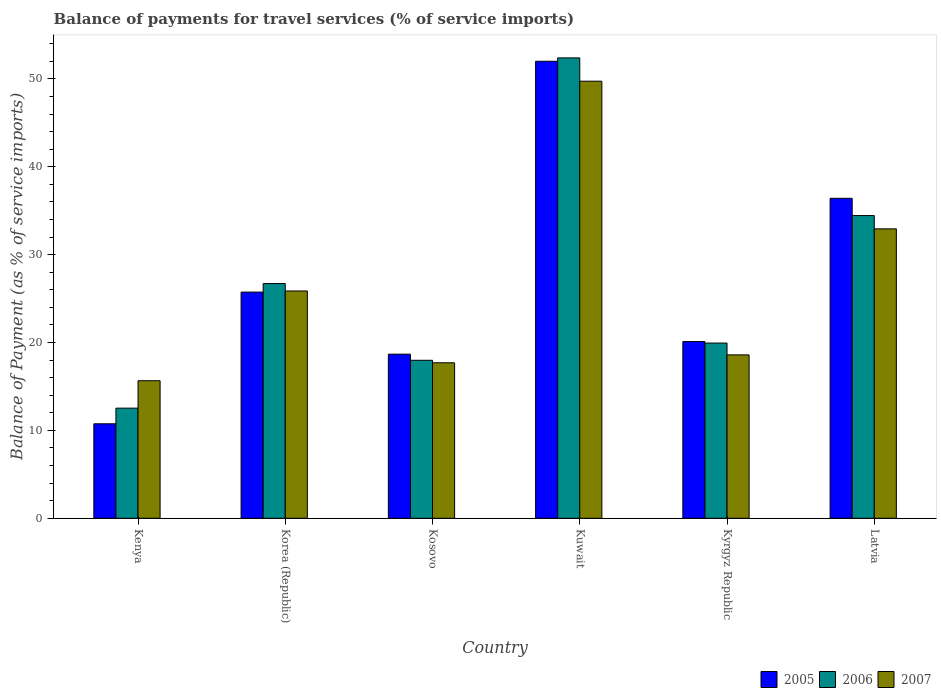How many different coloured bars are there?
Provide a short and direct response. 3. Are the number of bars per tick equal to the number of legend labels?
Keep it short and to the point. Yes. Are the number of bars on each tick of the X-axis equal?
Keep it short and to the point. Yes. What is the label of the 5th group of bars from the left?
Provide a succinct answer. Kyrgyz Republic. What is the balance of payments for travel services in 2007 in Latvia?
Offer a terse response. 32.93. Across all countries, what is the maximum balance of payments for travel services in 2007?
Your answer should be very brief. 49.73. Across all countries, what is the minimum balance of payments for travel services in 2006?
Keep it short and to the point. 12.53. In which country was the balance of payments for travel services in 2005 maximum?
Ensure brevity in your answer.  Kuwait. In which country was the balance of payments for travel services in 2005 minimum?
Your answer should be very brief. Kenya. What is the total balance of payments for travel services in 2007 in the graph?
Give a very brief answer. 160.46. What is the difference between the balance of payments for travel services in 2005 in Kenya and that in Kosovo?
Keep it short and to the point. -7.92. What is the difference between the balance of payments for travel services in 2007 in Korea (Republic) and the balance of payments for travel services in 2005 in Kuwait?
Your answer should be very brief. -26.14. What is the average balance of payments for travel services in 2006 per country?
Keep it short and to the point. 27.33. What is the difference between the balance of payments for travel services of/in 2007 and balance of payments for travel services of/in 2005 in Latvia?
Provide a short and direct response. -3.47. In how many countries, is the balance of payments for travel services in 2006 greater than 32 %?
Make the answer very short. 2. What is the ratio of the balance of payments for travel services in 2005 in Korea (Republic) to that in Kosovo?
Keep it short and to the point. 1.38. Is the balance of payments for travel services in 2006 in Kyrgyz Republic less than that in Latvia?
Your answer should be compact. Yes. Is the difference between the balance of payments for travel services in 2007 in Kosovo and Kuwait greater than the difference between the balance of payments for travel services in 2005 in Kosovo and Kuwait?
Provide a succinct answer. Yes. What is the difference between the highest and the second highest balance of payments for travel services in 2007?
Keep it short and to the point. -16.8. What is the difference between the highest and the lowest balance of payments for travel services in 2007?
Provide a short and direct response. 34.08. Is the sum of the balance of payments for travel services in 2006 in Kosovo and Latvia greater than the maximum balance of payments for travel services in 2007 across all countries?
Make the answer very short. Yes. What does the 2nd bar from the left in Kenya represents?
Offer a terse response. 2006. What does the 1st bar from the right in Kenya represents?
Offer a terse response. 2007. Is it the case that in every country, the sum of the balance of payments for travel services in 2006 and balance of payments for travel services in 2005 is greater than the balance of payments for travel services in 2007?
Ensure brevity in your answer.  Yes. How many bars are there?
Your response must be concise. 18. Are all the bars in the graph horizontal?
Offer a terse response. No. Does the graph contain any zero values?
Your answer should be very brief. No. Does the graph contain grids?
Offer a terse response. No. Where does the legend appear in the graph?
Your answer should be compact. Bottom right. What is the title of the graph?
Keep it short and to the point. Balance of payments for travel services (% of service imports). What is the label or title of the X-axis?
Your answer should be very brief. Country. What is the label or title of the Y-axis?
Make the answer very short. Balance of Payment (as % of service imports). What is the Balance of Payment (as % of service imports) of 2005 in Kenya?
Keep it short and to the point. 10.75. What is the Balance of Payment (as % of service imports) in 2006 in Kenya?
Provide a succinct answer. 12.53. What is the Balance of Payment (as % of service imports) of 2007 in Kenya?
Make the answer very short. 15.65. What is the Balance of Payment (as % of service imports) in 2005 in Korea (Republic)?
Make the answer very short. 25.74. What is the Balance of Payment (as % of service imports) in 2006 in Korea (Republic)?
Give a very brief answer. 26.71. What is the Balance of Payment (as % of service imports) of 2007 in Korea (Republic)?
Ensure brevity in your answer.  25.86. What is the Balance of Payment (as % of service imports) in 2005 in Kosovo?
Your answer should be compact. 18.67. What is the Balance of Payment (as % of service imports) of 2006 in Kosovo?
Provide a short and direct response. 17.98. What is the Balance of Payment (as % of service imports) in 2007 in Kosovo?
Your answer should be compact. 17.69. What is the Balance of Payment (as % of service imports) of 2005 in Kuwait?
Your answer should be very brief. 52. What is the Balance of Payment (as % of service imports) of 2006 in Kuwait?
Give a very brief answer. 52.38. What is the Balance of Payment (as % of service imports) of 2007 in Kuwait?
Offer a terse response. 49.73. What is the Balance of Payment (as % of service imports) of 2005 in Kyrgyz Republic?
Provide a short and direct response. 20.11. What is the Balance of Payment (as % of service imports) in 2006 in Kyrgyz Republic?
Keep it short and to the point. 19.94. What is the Balance of Payment (as % of service imports) in 2007 in Kyrgyz Republic?
Give a very brief answer. 18.59. What is the Balance of Payment (as % of service imports) of 2005 in Latvia?
Your answer should be very brief. 36.41. What is the Balance of Payment (as % of service imports) in 2006 in Latvia?
Your answer should be very brief. 34.44. What is the Balance of Payment (as % of service imports) of 2007 in Latvia?
Offer a terse response. 32.93. Across all countries, what is the maximum Balance of Payment (as % of service imports) in 2005?
Make the answer very short. 52. Across all countries, what is the maximum Balance of Payment (as % of service imports) of 2006?
Your response must be concise. 52.38. Across all countries, what is the maximum Balance of Payment (as % of service imports) of 2007?
Provide a succinct answer. 49.73. Across all countries, what is the minimum Balance of Payment (as % of service imports) of 2005?
Keep it short and to the point. 10.75. Across all countries, what is the minimum Balance of Payment (as % of service imports) in 2006?
Keep it short and to the point. 12.53. Across all countries, what is the minimum Balance of Payment (as % of service imports) of 2007?
Keep it short and to the point. 15.65. What is the total Balance of Payment (as % of service imports) of 2005 in the graph?
Your answer should be compact. 163.68. What is the total Balance of Payment (as % of service imports) in 2006 in the graph?
Keep it short and to the point. 163.98. What is the total Balance of Payment (as % of service imports) of 2007 in the graph?
Keep it short and to the point. 160.46. What is the difference between the Balance of Payment (as % of service imports) of 2005 in Kenya and that in Korea (Republic)?
Make the answer very short. -14.99. What is the difference between the Balance of Payment (as % of service imports) in 2006 in Kenya and that in Korea (Republic)?
Offer a very short reply. -14.18. What is the difference between the Balance of Payment (as % of service imports) in 2007 in Kenya and that in Korea (Republic)?
Make the answer very short. -10.21. What is the difference between the Balance of Payment (as % of service imports) in 2005 in Kenya and that in Kosovo?
Your response must be concise. -7.92. What is the difference between the Balance of Payment (as % of service imports) in 2006 in Kenya and that in Kosovo?
Make the answer very short. -5.44. What is the difference between the Balance of Payment (as % of service imports) of 2007 in Kenya and that in Kosovo?
Offer a terse response. -2.04. What is the difference between the Balance of Payment (as % of service imports) in 2005 in Kenya and that in Kuwait?
Provide a succinct answer. -41.25. What is the difference between the Balance of Payment (as % of service imports) in 2006 in Kenya and that in Kuwait?
Your answer should be very brief. -39.85. What is the difference between the Balance of Payment (as % of service imports) in 2007 in Kenya and that in Kuwait?
Provide a succinct answer. -34.08. What is the difference between the Balance of Payment (as % of service imports) in 2005 in Kenya and that in Kyrgyz Republic?
Make the answer very short. -9.36. What is the difference between the Balance of Payment (as % of service imports) in 2006 in Kenya and that in Kyrgyz Republic?
Offer a terse response. -7.41. What is the difference between the Balance of Payment (as % of service imports) of 2007 in Kenya and that in Kyrgyz Republic?
Offer a very short reply. -2.94. What is the difference between the Balance of Payment (as % of service imports) of 2005 in Kenya and that in Latvia?
Keep it short and to the point. -25.66. What is the difference between the Balance of Payment (as % of service imports) of 2006 in Kenya and that in Latvia?
Your response must be concise. -21.91. What is the difference between the Balance of Payment (as % of service imports) of 2007 in Kenya and that in Latvia?
Make the answer very short. -17.28. What is the difference between the Balance of Payment (as % of service imports) in 2005 in Korea (Republic) and that in Kosovo?
Offer a terse response. 7.06. What is the difference between the Balance of Payment (as % of service imports) in 2006 in Korea (Republic) and that in Kosovo?
Offer a very short reply. 8.73. What is the difference between the Balance of Payment (as % of service imports) in 2007 in Korea (Republic) and that in Kosovo?
Give a very brief answer. 8.17. What is the difference between the Balance of Payment (as % of service imports) of 2005 in Korea (Republic) and that in Kuwait?
Keep it short and to the point. -26.27. What is the difference between the Balance of Payment (as % of service imports) in 2006 in Korea (Republic) and that in Kuwait?
Provide a succinct answer. -25.68. What is the difference between the Balance of Payment (as % of service imports) of 2007 in Korea (Republic) and that in Kuwait?
Ensure brevity in your answer.  -23.87. What is the difference between the Balance of Payment (as % of service imports) in 2005 in Korea (Republic) and that in Kyrgyz Republic?
Provide a succinct answer. 5.63. What is the difference between the Balance of Payment (as % of service imports) of 2006 in Korea (Republic) and that in Kyrgyz Republic?
Provide a short and direct response. 6.77. What is the difference between the Balance of Payment (as % of service imports) of 2007 in Korea (Republic) and that in Kyrgyz Republic?
Offer a very short reply. 7.27. What is the difference between the Balance of Payment (as % of service imports) of 2005 in Korea (Republic) and that in Latvia?
Provide a succinct answer. -10.67. What is the difference between the Balance of Payment (as % of service imports) of 2006 in Korea (Republic) and that in Latvia?
Your answer should be compact. -7.74. What is the difference between the Balance of Payment (as % of service imports) of 2007 in Korea (Republic) and that in Latvia?
Ensure brevity in your answer.  -7.07. What is the difference between the Balance of Payment (as % of service imports) in 2005 in Kosovo and that in Kuwait?
Your answer should be very brief. -33.33. What is the difference between the Balance of Payment (as % of service imports) of 2006 in Kosovo and that in Kuwait?
Offer a terse response. -34.41. What is the difference between the Balance of Payment (as % of service imports) of 2007 in Kosovo and that in Kuwait?
Your answer should be very brief. -32.04. What is the difference between the Balance of Payment (as % of service imports) of 2005 in Kosovo and that in Kyrgyz Republic?
Keep it short and to the point. -1.44. What is the difference between the Balance of Payment (as % of service imports) in 2006 in Kosovo and that in Kyrgyz Republic?
Make the answer very short. -1.96. What is the difference between the Balance of Payment (as % of service imports) of 2007 in Kosovo and that in Kyrgyz Republic?
Give a very brief answer. -0.9. What is the difference between the Balance of Payment (as % of service imports) in 2005 in Kosovo and that in Latvia?
Provide a short and direct response. -17.73. What is the difference between the Balance of Payment (as % of service imports) in 2006 in Kosovo and that in Latvia?
Keep it short and to the point. -16.47. What is the difference between the Balance of Payment (as % of service imports) in 2007 in Kosovo and that in Latvia?
Keep it short and to the point. -15.24. What is the difference between the Balance of Payment (as % of service imports) in 2005 in Kuwait and that in Kyrgyz Republic?
Give a very brief answer. 31.89. What is the difference between the Balance of Payment (as % of service imports) of 2006 in Kuwait and that in Kyrgyz Republic?
Offer a terse response. 32.45. What is the difference between the Balance of Payment (as % of service imports) in 2007 in Kuwait and that in Kyrgyz Republic?
Offer a very short reply. 31.14. What is the difference between the Balance of Payment (as % of service imports) in 2005 in Kuwait and that in Latvia?
Offer a very short reply. 15.6. What is the difference between the Balance of Payment (as % of service imports) of 2006 in Kuwait and that in Latvia?
Make the answer very short. 17.94. What is the difference between the Balance of Payment (as % of service imports) in 2007 in Kuwait and that in Latvia?
Give a very brief answer. 16.8. What is the difference between the Balance of Payment (as % of service imports) in 2005 in Kyrgyz Republic and that in Latvia?
Provide a short and direct response. -16.3. What is the difference between the Balance of Payment (as % of service imports) of 2006 in Kyrgyz Republic and that in Latvia?
Offer a terse response. -14.51. What is the difference between the Balance of Payment (as % of service imports) in 2007 in Kyrgyz Republic and that in Latvia?
Ensure brevity in your answer.  -14.34. What is the difference between the Balance of Payment (as % of service imports) of 2005 in Kenya and the Balance of Payment (as % of service imports) of 2006 in Korea (Republic)?
Offer a terse response. -15.96. What is the difference between the Balance of Payment (as % of service imports) in 2005 in Kenya and the Balance of Payment (as % of service imports) in 2007 in Korea (Republic)?
Keep it short and to the point. -15.11. What is the difference between the Balance of Payment (as % of service imports) of 2006 in Kenya and the Balance of Payment (as % of service imports) of 2007 in Korea (Republic)?
Keep it short and to the point. -13.33. What is the difference between the Balance of Payment (as % of service imports) of 2005 in Kenya and the Balance of Payment (as % of service imports) of 2006 in Kosovo?
Provide a succinct answer. -7.23. What is the difference between the Balance of Payment (as % of service imports) in 2005 in Kenya and the Balance of Payment (as % of service imports) in 2007 in Kosovo?
Your response must be concise. -6.94. What is the difference between the Balance of Payment (as % of service imports) of 2006 in Kenya and the Balance of Payment (as % of service imports) of 2007 in Kosovo?
Offer a terse response. -5.16. What is the difference between the Balance of Payment (as % of service imports) of 2005 in Kenya and the Balance of Payment (as % of service imports) of 2006 in Kuwait?
Your response must be concise. -41.63. What is the difference between the Balance of Payment (as % of service imports) in 2005 in Kenya and the Balance of Payment (as % of service imports) in 2007 in Kuwait?
Your response must be concise. -38.98. What is the difference between the Balance of Payment (as % of service imports) in 2006 in Kenya and the Balance of Payment (as % of service imports) in 2007 in Kuwait?
Provide a short and direct response. -37.2. What is the difference between the Balance of Payment (as % of service imports) of 2005 in Kenya and the Balance of Payment (as % of service imports) of 2006 in Kyrgyz Republic?
Keep it short and to the point. -9.19. What is the difference between the Balance of Payment (as % of service imports) of 2005 in Kenya and the Balance of Payment (as % of service imports) of 2007 in Kyrgyz Republic?
Provide a succinct answer. -7.84. What is the difference between the Balance of Payment (as % of service imports) in 2006 in Kenya and the Balance of Payment (as % of service imports) in 2007 in Kyrgyz Republic?
Give a very brief answer. -6.06. What is the difference between the Balance of Payment (as % of service imports) of 2005 in Kenya and the Balance of Payment (as % of service imports) of 2006 in Latvia?
Keep it short and to the point. -23.69. What is the difference between the Balance of Payment (as % of service imports) in 2005 in Kenya and the Balance of Payment (as % of service imports) in 2007 in Latvia?
Make the answer very short. -22.18. What is the difference between the Balance of Payment (as % of service imports) of 2006 in Kenya and the Balance of Payment (as % of service imports) of 2007 in Latvia?
Provide a short and direct response. -20.4. What is the difference between the Balance of Payment (as % of service imports) in 2005 in Korea (Republic) and the Balance of Payment (as % of service imports) in 2006 in Kosovo?
Ensure brevity in your answer.  7.76. What is the difference between the Balance of Payment (as % of service imports) of 2005 in Korea (Republic) and the Balance of Payment (as % of service imports) of 2007 in Kosovo?
Ensure brevity in your answer.  8.04. What is the difference between the Balance of Payment (as % of service imports) of 2006 in Korea (Republic) and the Balance of Payment (as % of service imports) of 2007 in Kosovo?
Your response must be concise. 9.02. What is the difference between the Balance of Payment (as % of service imports) of 2005 in Korea (Republic) and the Balance of Payment (as % of service imports) of 2006 in Kuwait?
Your answer should be compact. -26.65. What is the difference between the Balance of Payment (as % of service imports) in 2005 in Korea (Republic) and the Balance of Payment (as % of service imports) in 2007 in Kuwait?
Your answer should be very brief. -24. What is the difference between the Balance of Payment (as % of service imports) of 2006 in Korea (Republic) and the Balance of Payment (as % of service imports) of 2007 in Kuwait?
Offer a very short reply. -23.02. What is the difference between the Balance of Payment (as % of service imports) of 2005 in Korea (Republic) and the Balance of Payment (as % of service imports) of 2006 in Kyrgyz Republic?
Provide a short and direct response. 5.8. What is the difference between the Balance of Payment (as % of service imports) of 2005 in Korea (Republic) and the Balance of Payment (as % of service imports) of 2007 in Kyrgyz Republic?
Your answer should be very brief. 7.15. What is the difference between the Balance of Payment (as % of service imports) in 2006 in Korea (Republic) and the Balance of Payment (as % of service imports) in 2007 in Kyrgyz Republic?
Offer a terse response. 8.12. What is the difference between the Balance of Payment (as % of service imports) in 2005 in Korea (Republic) and the Balance of Payment (as % of service imports) in 2006 in Latvia?
Your response must be concise. -8.71. What is the difference between the Balance of Payment (as % of service imports) of 2005 in Korea (Republic) and the Balance of Payment (as % of service imports) of 2007 in Latvia?
Your answer should be compact. -7.2. What is the difference between the Balance of Payment (as % of service imports) in 2006 in Korea (Republic) and the Balance of Payment (as % of service imports) in 2007 in Latvia?
Offer a very short reply. -6.22. What is the difference between the Balance of Payment (as % of service imports) in 2005 in Kosovo and the Balance of Payment (as % of service imports) in 2006 in Kuwait?
Provide a succinct answer. -33.71. What is the difference between the Balance of Payment (as % of service imports) of 2005 in Kosovo and the Balance of Payment (as % of service imports) of 2007 in Kuwait?
Ensure brevity in your answer.  -31.06. What is the difference between the Balance of Payment (as % of service imports) in 2006 in Kosovo and the Balance of Payment (as % of service imports) in 2007 in Kuwait?
Make the answer very short. -31.76. What is the difference between the Balance of Payment (as % of service imports) in 2005 in Kosovo and the Balance of Payment (as % of service imports) in 2006 in Kyrgyz Republic?
Give a very brief answer. -1.26. What is the difference between the Balance of Payment (as % of service imports) in 2005 in Kosovo and the Balance of Payment (as % of service imports) in 2007 in Kyrgyz Republic?
Provide a succinct answer. 0.08. What is the difference between the Balance of Payment (as % of service imports) of 2006 in Kosovo and the Balance of Payment (as % of service imports) of 2007 in Kyrgyz Republic?
Offer a very short reply. -0.62. What is the difference between the Balance of Payment (as % of service imports) of 2005 in Kosovo and the Balance of Payment (as % of service imports) of 2006 in Latvia?
Your answer should be compact. -15.77. What is the difference between the Balance of Payment (as % of service imports) in 2005 in Kosovo and the Balance of Payment (as % of service imports) in 2007 in Latvia?
Keep it short and to the point. -14.26. What is the difference between the Balance of Payment (as % of service imports) of 2006 in Kosovo and the Balance of Payment (as % of service imports) of 2007 in Latvia?
Ensure brevity in your answer.  -14.96. What is the difference between the Balance of Payment (as % of service imports) of 2005 in Kuwait and the Balance of Payment (as % of service imports) of 2006 in Kyrgyz Republic?
Offer a terse response. 32.07. What is the difference between the Balance of Payment (as % of service imports) of 2005 in Kuwait and the Balance of Payment (as % of service imports) of 2007 in Kyrgyz Republic?
Offer a terse response. 33.41. What is the difference between the Balance of Payment (as % of service imports) of 2006 in Kuwait and the Balance of Payment (as % of service imports) of 2007 in Kyrgyz Republic?
Provide a short and direct response. 33.79. What is the difference between the Balance of Payment (as % of service imports) in 2005 in Kuwait and the Balance of Payment (as % of service imports) in 2006 in Latvia?
Your answer should be compact. 17.56. What is the difference between the Balance of Payment (as % of service imports) in 2005 in Kuwait and the Balance of Payment (as % of service imports) in 2007 in Latvia?
Keep it short and to the point. 19.07. What is the difference between the Balance of Payment (as % of service imports) in 2006 in Kuwait and the Balance of Payment (as % of service imports) in 2007 in Latvia?
Offer a very short reply. 19.45. What is the difference between the Balance of Payment (as % of service imports) of 2005 in Kyrgyz Republic and the Balance of Payment (as % of service imports) of 2006 in Latvia?
Your response must be concise. -14.33. What is the difference between the Balance of Payment (as % of service imports) in 2005 in Kyrgyz Republic and the Balance of Payment (as % of service imports) in 2007 in Latvia?
Provide a short and direct response. -12.82. What is the difference between the Balance of Payment (as % of service imports) of 2006 in Kyrgyz Republic and the Balance of Payment (as % of service imports) of 2007 in Latvia?
Offer a very short reply. -12.99. What is the average Balance of Payment (as % of service imports) of 2005 per country?
Ensure brevity in your answer.  27.28. What is the average Balance of Payment (as % of service imports) in 2006 per country?
Your response must be concise. 27.33. What is the average Balance of Payment (as % of service imports) of 2007 per country?
Keep it short and to the point. 26.74. What is the difference between the Balance of Payment (as % of service imports) of 2005 and Balance of Payment (as % of service imports) of 2006 in Kenya?
Provide a succinct answer. -1.78. What is the difference between the Balance of Payment (as % of service imports) of 2005 and Balance of Payment (as % of service imports) of 2007 in Kenya?
Your response must be concise. -4.9. What is the difference between the Balance of Payment (as % of service imports) of 2006 and Balance of Payment (as % of service imports) of 2007 in Kenya?
Your response must be concise. -3.12. What is the difference between the Balance of Payment (as % of service imports) of 2005 and Balance of Payment (as % of service imports) of 2006 in Korea (Republic)?
Your answer should be very brief. -0.97. What is the difference between the Balance of Payment (as % of service imports) in 2005 and Balance of Payment (as % of service imports) in 2007 in Korea (Republic)?
Offer a terse response. -0.13. What is the difference between the Balance of Payment (as % of service imports) in 2006 and Balance of Payment (as % of service imports) in 2007 in Korea (Republic)?
Your answer should be very brief. 0.84. What is the difference between the Balance of Payment (as % of service imports) of 2005 and Balance of Payment (as % of service imports) of 2006 in Kosovo?
Your answer should be compact. 0.7. What is the difference between the Balance of Payment (as % of service imports) in 2005 and Balance of Payment (as % of service imports) in 2007 in Kosovo?
Ensure brevity in your answer.  0.98. What is the difference between the Balance of Payment (as % of service imports) of 2006 and Balance of Payment (as % of service imports) of 2007 in Kosovo?
Provide a succinct answer. 0.28. What is the difference between the Balance of Payment (as % of service imports) in 2005 and Balance of Payment (as % of service imports) in 2006 in Kuwait?
Offer a terse response. -0.38. What is the difference between the Balance of Payment (as % of service imports) in 2005 and Balance of Payment (as % of service imports) in 2007 in Kuwait?
Offer a terse response. 2.27. What is the difference between the Balance of Payment (as % of service imports) of 2006 and Balance of Payment (as % of service imports) of 2007 in Kuwait?
Offer a very short reply. 2.65. What is the difference between the Balance of Payment (as % of service imports) in 2005 and Balance of Payment (as % of service imports) in 2006 in Kyrgyz Republic?
Your response must be concise. 0.17. What is the difference between the Balance of Payment (as % of service imports) of 2005 and Balance of Payment (as % of service imports) of 2007 in Kyrgyz Republic?
Your response must be concise. 1.52. What is the difference between the Balance of Payment (as % of service imports) of 2006 and Balance of Payment (as % of service imports) of 2007 in Kyrgyz Republic?
Provide a succinct answer. 1.35. What is the difference between the Balance of Payment (as % of service imports) in 2005 and Balance of Payment (as % of service imports) in 2006 in Latvia?
Provide a short and direct response. 1.96. What is the difference between the Balance of Payment (as % of service imports) of 2005 and Balance of Payment (as % of service imports) of 2007 in Latvia?
Give a very brief answer. 3.47. What is the difference between the Balance of Payment (as % of service imports) of 2006 and Balance of Payment (as % of service imports) of 2007 in Latvia?
Give a very brief answer. 1.51. What is the ratio of the Balance of Payment (as % of service imports) in 2005 in Kenya to that in Korea (Republic)?
Your answer should be very brief. 0.42. What is the ratio of the Balance of Payment (as % of service imports) of 2006 in Kenya to that in Korea (Republic)?
Provide a succinct answer. 0.47. What is the ratio of the Balance of Payment (as % of service imports) in 2007 in Kenya to that in Korea (Republic)?
Your response must be concise. 0.61. What is the ratio of the Balance of Payment (as % of service imports) in 2005 in Kenya to that in Kosovo?
Keep it short and to the point. 0.58. What is the ratio of the Balance of Payment (as % of service imports) in 2006 in Kenya to that in Kosovo?
Your response must be concise. 0.7. What is the ratio of the Balance of Payment (as % of service imports) of 2007 in Kenya to that in Kosovo?
Provide a succinct answer. 0.88. What is the ratio of the Balance of Payment (as % of service imports) of 2005 in Kenya to that in Kuwait?
Your answer should be compact. 0.21. What is the ratio of the Balance of Payment (as % of service imports) of 2006 in Kenya to that in Kuwait?
Keep it short and to the point. 0.24. What is the ratio of the Balance of Payment (as % of service imports) in 2007 in Kenya to that in Kuwait?
Offer a very short reply. 0.31. What is the ratio of the Balance of Payment (as % of service imports) in 2005 in Kenya to that in Kyrgyz Republic?
Offer a very short reply. 0.53. What is the ratio of the Balance of Payment (as % of service imports) of 2006 in Kenya to that in Kyrgyz Republic?
Your answer should be very brief. 0.63. What is the ratio of the Balance of Payment (as % of service imports) in 2007 in Kenya to that in Kyrgyz Republic?
Ensure brevity in your answer.  0.84. What is the ratio of the Balance of Payment (as % of service imports) of 2005 in Kenya to that in Latvia?
Offer a terse response. 0.3. What is the ratio of the Balance of Payment (as % of service imports) in 2006 in Kenya to that in Latvia?
Make the answer very short. 0.36. What is the ratio of the Balance of Payment (as % of service imports) in 2007 in Kenya to that in Latvia?
Make the answer very short. 0.48. What is the ratio of the Balance of Payment (as % of service imports) in 2005 in Korea (Republic) to that in Kosovo?
Your answer should be compact. 1.38. What is the ratio of the Balance of Payment (as % of service imports) of 2006 in Korea (Republic) to that in Kosovo?
Provide a short and direct response. 1.49. What is the ratio of the Balance of Payment (as % of service imports) of 2007 in Korea (Republic) to that in Kosovo?
Your answer should be very brief. 1.46. What is the ratio of the Balance of Payment (as % of service imports) in 2005 in Korea (Republic) to that in Kuwait?
Your answer should be very brief. 0.49. What is the ratio of the Balance of Payment (as % of service imports) in 2006 in Korea (Republic) to that in Kuwait?
Provide a succinct answer. 0.51. What is the ratio of the Balance of Payment (as % of service imports) in 2007 in Korea (Republic) to that in Kuwait?
Your answer should be compact. 0.52. What is the ratio of the Balance of Payment (as % of service imports) in 2005 in Korea (Republic) to that in Kyrgyz Republic?
Offer a very short reply. 1.28. What is the ratio of the Balance of Payment (as % of service imports) of 2006 in Korea (Republic) to that in Kyrgyz Republic?
Offer a terse response. 1.34. What is the ratio of the Balance of Payment (as % of service imports) of 2007 in Korea (Republic) to that in Kyrgyz Republic?
Provide a succinct answer. 1.39. What is the ratio of the Balance of Payment (as % of service imports) of 2005 in Korea (Republic) to that in Latvia?
Offer a terse response. 0.71. What is the ratio of the Balance of Payment (as % of service imports) in 2006 in Korea (Republic) to that in Latvia?
Ensure brevity in your answer.  0.78. What is the ratio of the Balance of Payment (as % of service imports) of 2007 in Korea (Republic) to that in Latvia?
Offer a terse response. 0.79. What is the ratio of the Balance of Payment (as % of service imports) of 2005 in Kosovo to that in Kuwait?
Your response must be concise. 0.36. What is the ratio of the Balance of Payment (as % of service imports) in 2006 in Kosovo to that in Kuwait?
Your answer should be compact. 0.34. What is the ratio of the Balance of Payment (as % of service imports) in 2007 in Kosovo to that in Kuwait?
Ensure brevity in your answer.  0.36. What is the ratio of the Balance of Payment (as % of service imports) in 2005 in Kosovo to that in Kyrgyz Republic?
Give a very brief answer. 0.93. What is the ratio of the Balance of Payment (as % of service imports) in 2006 in Kosovo to that in Kyrgyz Republic?
Provide a succinct answer. 0.9. What is the ratio of the Balance of Payment (as % of service imports) in 2007 in Kosovo to that in Kyrgyz Republic?
Give a very brief answer. 0.95. What is the ratio of the Balance of Payment (as % of service imports) of 2005 in Kosovo to that in Latvia?
Provide a succinct answer. 0.51. What is the ratio of the Balance of Payment (as % of service imports) of 2006 in Kosovo to that in Latvia?
Your answer should be very brief. 0.52. What is the ratio of the Balance of Payment (as % of service imports) in 2007 in Kosovo to that in Latvia?
Make the answer very short. 0.54. What is the ratio of the Balance of Payment (as % of service imports) in 2005 in Kuwait to that in Kyrgyz Republic?
Ensure brevity in your answer.  2.59. What is the ratio of the Balance of Payment (as % of service imports) of 2006 in Kuwait to that in Kyrgyz Republic?
Give a very brief answer. 2.63. What is the ratio of the Balance of Payment (as % of service imports) of 2007 in Kuwait to that in Kyrgyz Republic?
Your answer should be very brief. 2.68. What is the ratio of the Balance of Payment (as % of service imports) in 2005 in Kuwait to that in Latvia?
Ensure brevity in your answer.  1.43. What is the ratio of the Balance of Payment (as % of service imports) of 2006 in Kuwait to that in Latvia?
Offer a very short reply. 1.52. What is the ratio of the Balance of Payment (as % of service imports) of 2007 in Kuwait to that in Latvia?
Keep it short and to the point. 1.51. What is the ratio of the Balance of Payment (as % of service imports) in 2005 in Kyrgyz Republic to that in Latvia?
Ensure brevity in your answer.  0.55. What is the ratio of the Balance of Payment (as % of service imports) in 2006 in Kyrgyz Republic to that in Latvia?
Your answer should be compact. 0.58. What is the ratio of the Balance of Payment (as % of service imports) in 2007 in Kyrgyz Republic to that in Latvia?
Ensure brevity in your answer.  0.56. What is the difference between the highest and the second highest Balance of Payment (as % of service imports) of 2005?
Your answer should be compact. 15.6. What is the difference between the highest and the second highest Balance of Payment (as % of service imports) of 2006?
Provide a short and direct response. 17.94. What is the difference between the highest and the second highest Balance of Payment (as % of service imports) of 2007?
Provide a succinct answer. 16.8. What is the difference between the highest and the lowest Balance of Payment (as % of service imports) of 2005?
Keep it short and to the point. 41.25. What is the difference between the highest and the lowest Balance of Payment (as % of service imports) of 2006?
Give a very brief answer. 39.85. What is the difference between the highest and the lowest Balance of Payment (as % of service imports) in 2007?
Give a very brief answer. 34.08. 